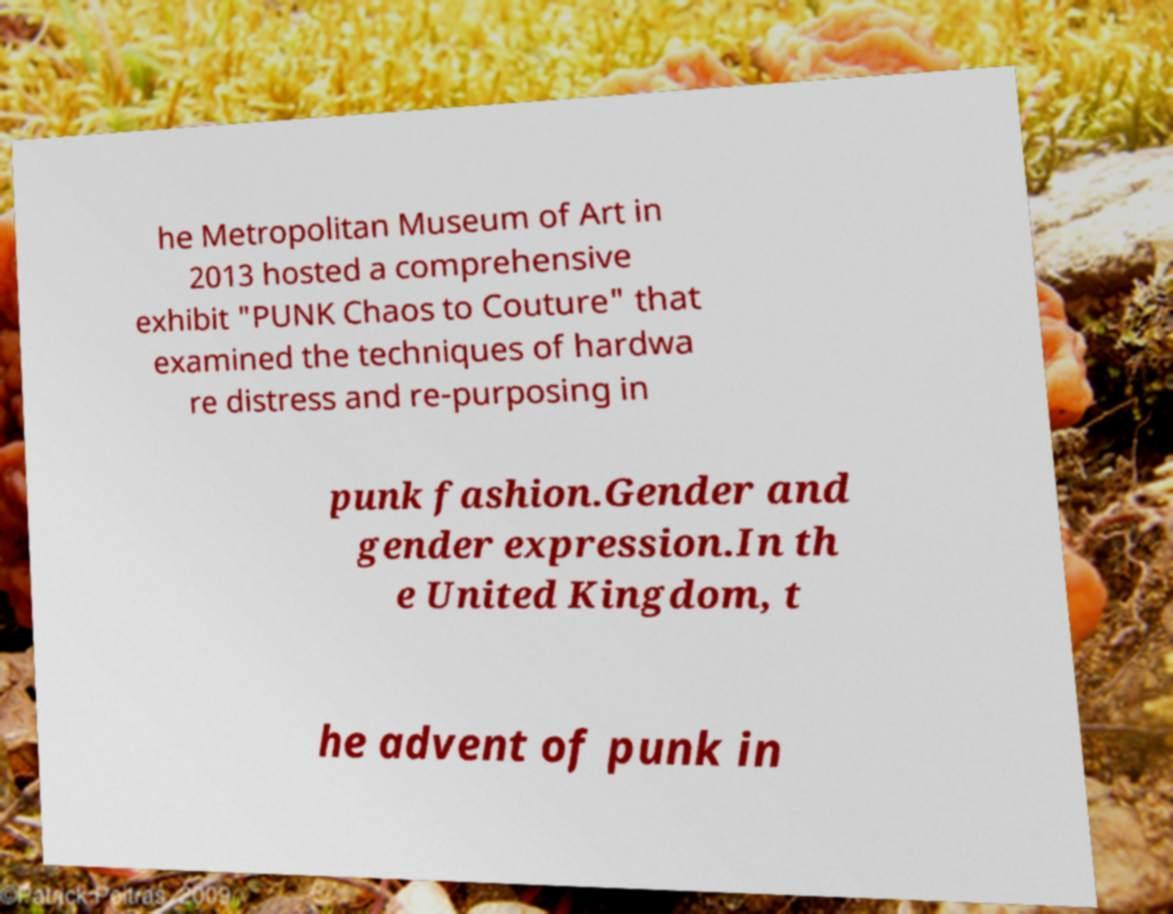For documentation purposes, I need the text within this image transcribed. Could you provide that? he Metropolitan Museum of Art in 2013 hosted a comprehensive exhibit "PUNK Chaos to Couture" that examined the techniques of hardwa re distress and re-purposing in punk fashion.Gender and gender expression.In th e United Kingdom, t he advent of punk in 